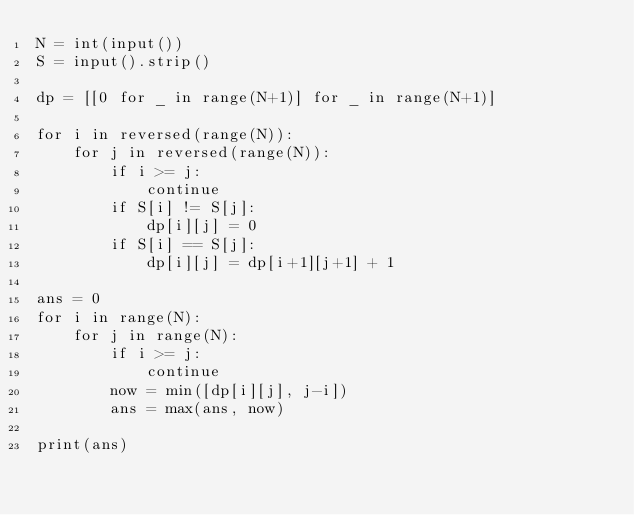<code> <loc_0><loc_0><loc_500><loc_500><_Python_>N = int(input())
S = input().strip()

dp = [[0 for _ in range(N+1)] for _ in range(N+1)]

for i in reversed(range(N)):
    for j in reversed(range(N)):
        if i >= j:
            continue
        if S[i] != S[j]:
            dp[i][j] = 0
        if S[i] == S[j]:
            dp[i][j] = dp[i+1][j+1] + 1

ans = 0
for i in range(N):
    for j in range(N):
        if i >= j:
            continue
        now = min([dp[i][j], j-i])
        ans = max(ans, now)

print(ans)
</code> 